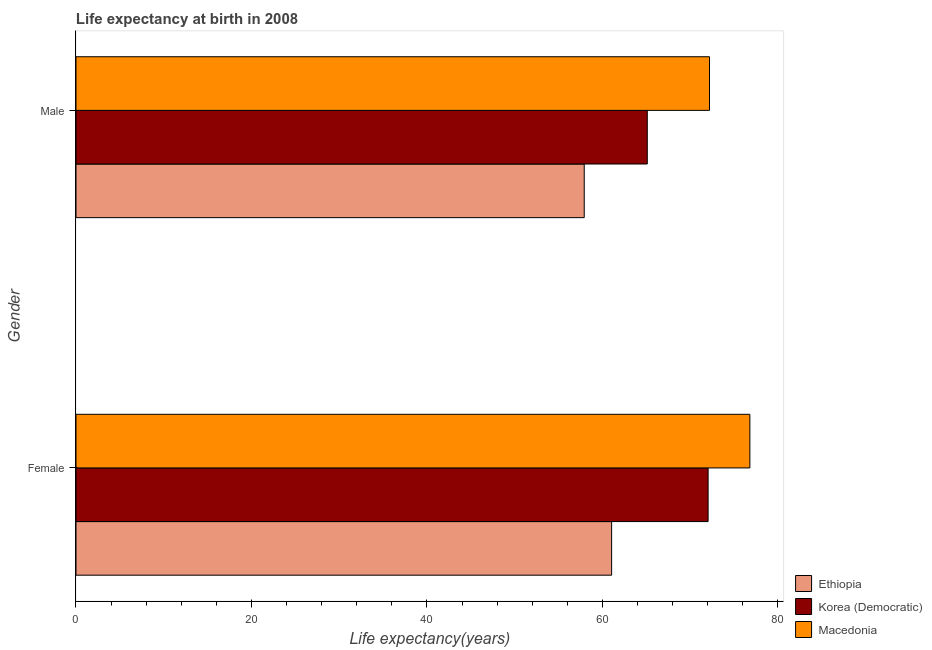How many groups of bars are there?
Provide a short and direct response. 2. Are the number of bars per tick equal to the number of legend labels?
Your answer should be compact. Yes. How many bars are there on the 1st tick from the bottom?
Make the answer very short. 3. What is the label of the 1st group of bars from the top?
Provide a short and direct response. Male. What is the life expectancy(male) in Ethiopia?
Provide a short and direct response. 57.92. Across all countries, what is the maximum life expectancy(male)?
Your answer should be very brief. 72.2. Across all countries, what is the minimum life expectancy(male)?
Offer a terse response. 57.92. In which country was the life expectancy(male) maximum?
Keep it short and to the point. Macedonia. In which country was the life expectancy(female) minimum?
Ensure brevity in your answer.  Ethiopia. What is the total life expectancy(female) in the graph?
Your response must be concise. 209.89. What is the difference between the life expectancy(male) in Macedonia and that in Korea (Democratic)?
Your answer should be compact. 7.09. What is the difference between the life expectancy(female) in Ethiopia and the life expectancy(male) in Korea (Democratic)?
Provide a succinct answer. -4.06. What is the average life expectancy(male) per country?
Your answer should be compact. 65.08. What is the difference between the life expectancy(male) and life expectancy(female) in Macedonia?
Make the answer very short. -4.6. In how many countries, is the life expectancy(male) greater than 52 years?
Your answer should be very brief. 3. What is the ratio of the life expectancy(female) in Ethiopia to that in Macedonia?
Ensure brevity in your answer.  0.79. In how many countries, is the life expectancy(female) greater than the average life expectancy(female) taken over all countries?
Make the answer very short. 2. What does the 1st bar from the top in Male represents?
Provide a short and direct response. Macedonia. What does the 3rd bar from the bottom in Female represents?
Provide a succinct answer. Macedonia. How many bars are there?
Your answer should be compact. 6. Are all the bars in the graph horizontal?
Provide a succinct answer. Yes. How many countries are there in the graph?
Ensure brevity in your answer.  3. What is the difference between two consecutive major ticks on the X-axis?
Ensure brevity in your answer.  20. Are the values on the major ticks of X-axis written in scientific E-notation?
Offer a very short reply. No. Does the graph contain grids?
Your response must be concise. No. Where does the legend appear in the graph?
Your response must be concise. Bottom right. How many legend labels are there?
Provide a short and direct response. 3. What is the title of the graph?
Your response must be concise. Life expectancy at birth in 2008. What is the label or title of the X-axis?
Provide a short and direct response. Life expectancy(years). What is the Life expectancy(years) in Ethiopia in Female?
Offer a very short reply. 61.05. What is the Life expectancy(years) of Korea (Democratic) in Female?
Provide a short and direct response. 72.04. What is the Life expectancy(years) in Macedonia in Female?
Offer a terse response. 76.8. What is the Life expectancy(years) of Ethiopia in Male?
Offer a very short reply. 57.92. What is the Life expectancy(years) in Korea (Democratic) in Male?
Offer a terse response. 65.11. What is the Life expectancy(years) of Macedonia in Male?
Provide a short and direct response. 72.2. Across all Gender, what is the maximum Life expectancy(years) of Ethiopia?
Your answer should be compact. 61.05. Across all Gender, what is the maximum Life expectancy(years) of Korea (Democratic)?
Offer a very short reply. 72.04. Across all Gender, what is the maximum Life expectancy(years) of Macedonia?
Make the answer very short. 76.8. Across all Gender, what is the minimum Life expectancy(years) of Ethiopia?
Ensure brevity in your answer.  57.92. Across all Gender, what is the minimum Life expectancy(years) in Korea (Democratic)?
Give a very brief answer. 65.11. Across all Gender, what is the minimum Life expectancy(years) of Macedonia?
Keep it short and to the point. 72.2. What is the total Life expectancy(years) of Ethiopia in the graph?
Keep it short and to the point. 118.97. What is the total Life expectancy(years) of Korea (Democratic) in the graph?
Make the answer very short. 137.15. What is the total Life expectancy(years) of Macedonia in the graph?
Provide a short and direct response. 149. What is the difference between the Life expectancy(years) of Ethiopia in Female and that in Male?
Provide a succinct answer. 3.12. What is the difference between the Life expectancy(years) in Korea (Democratic) in Female and that in Male?
Give a very brief answer. 6.93. What is the difference between the Life expectancy(years) of Macedonia in Female and that in Male?
Keep it short and to the point. 4.6. What is the difference between the Life expectancy(years) in Ethiopia in Female and the Life expectancy(years) in Korea (Democratic) in Male?
Keep it short and to the point. -4.06. What is the difference between the Life expectancy(years) of Ethiopia in Female and the Life expectancy(years) of Macedonia in Male?
Offer a very short reply. -11.16. What is the difference between the Life expectancy(years) in Korea (Democratic) in Female and the Life expectancy(years) in Macedonia in Male?
Give a very brief answer. -0.16. What is the average Life expectancy(years) in Ethiopia per Gender?
Give a very brief answer. 59.48. What is the average Life expectancy(years) of Korea (Democratic) per Gender?
Your response must be concise. 68.58. What is the average Life expectancy(years) in Macedonia per Gender?
Your answer should be compact. 74.5. What is the difference between the Life expectancy(years) in Ethiopia and Life expectancy(years) in Korea (Democratic) in Female?
Offer a terse response. -11. What is the difference between the Life expectancy(years) of Ethiopia and Life expectancy(years) of Macedonia in Female?
Your answer should be very brief. -15.76. What is the difference between the Life expectancy(years) of Korea (Democratic) and Life expectancy(years) of Macedonia in Female?
Give a very brief answer. -4.76. What is the difference between the Life expectancy(years) in Ethiopia and Life expectancy(years) in Korea (Democratic) in Male?
Make the answer very short. -7.19. What is the difference between the Life expectancy(years) of Ethiopia and Life expectancy(years) of Macedonia in Male?
Offer a very short reply. -14.28. What is the difference between the Life expectancy(years) of Korea (Democratic) and Life expectancy(years) of Macedonia in Male?
Keep it short and to the point. -7.09. What is the ratio of the Life expectancy(years) of Ethiopia in Female to that in Male?
Offer a terse response. 1.05. What is the ratio of the Life expectancy(years) in Korea (Democratic) in Female to that in Male?
Provide a succinct answer. 1.11. What is the ratio of the Life expectancy(years) of Macedonia in Female to that in Male?
Give a very brief answer. 1.06. What is the difference between the highest and the second highest Life expectancy(years) in Ethiopia?
Provide a succinct answer. 3.12. What is the difference between the highest and the second highest Life expectancy(years) of Korea (Democratic)?
Make the answer very short. 6.93. What is the difference between the highest and the second highest Life expectancy(years) of Macedonia?
Provide a short and direct response. 4.6. What is the difference between the highest and the lowest Life expectancy(years) of Ethiopia?
Keep it short and to the point. 3.12. What is the difference between the highest and the lowest Life expectancy(years) of Korea (Democratic)?
Provide a succinct answer. 6.93. What is the difference between the highest and the lowest Life expectancy(years) of Macedonia?
Make the answer very short. 4.6. 